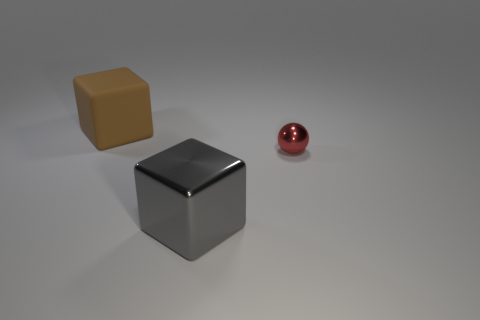Describe the texture of the objects shown. There are three objects with distinct textures. The brown cube has a matte finish, the silver cube a glossy finish, and the red sphere also sports a shiny, reflective surface, indicative of a glossy texture. How does the texture affect the way light interacts with these objects? The matte finish on the brown cube diffuses the light, resulting in an even distribution of shadows and soft reflections. The glossy textures on the silver cube and red sphere reflect the light more directly, creating sharper highlights and more distinct reflections. 